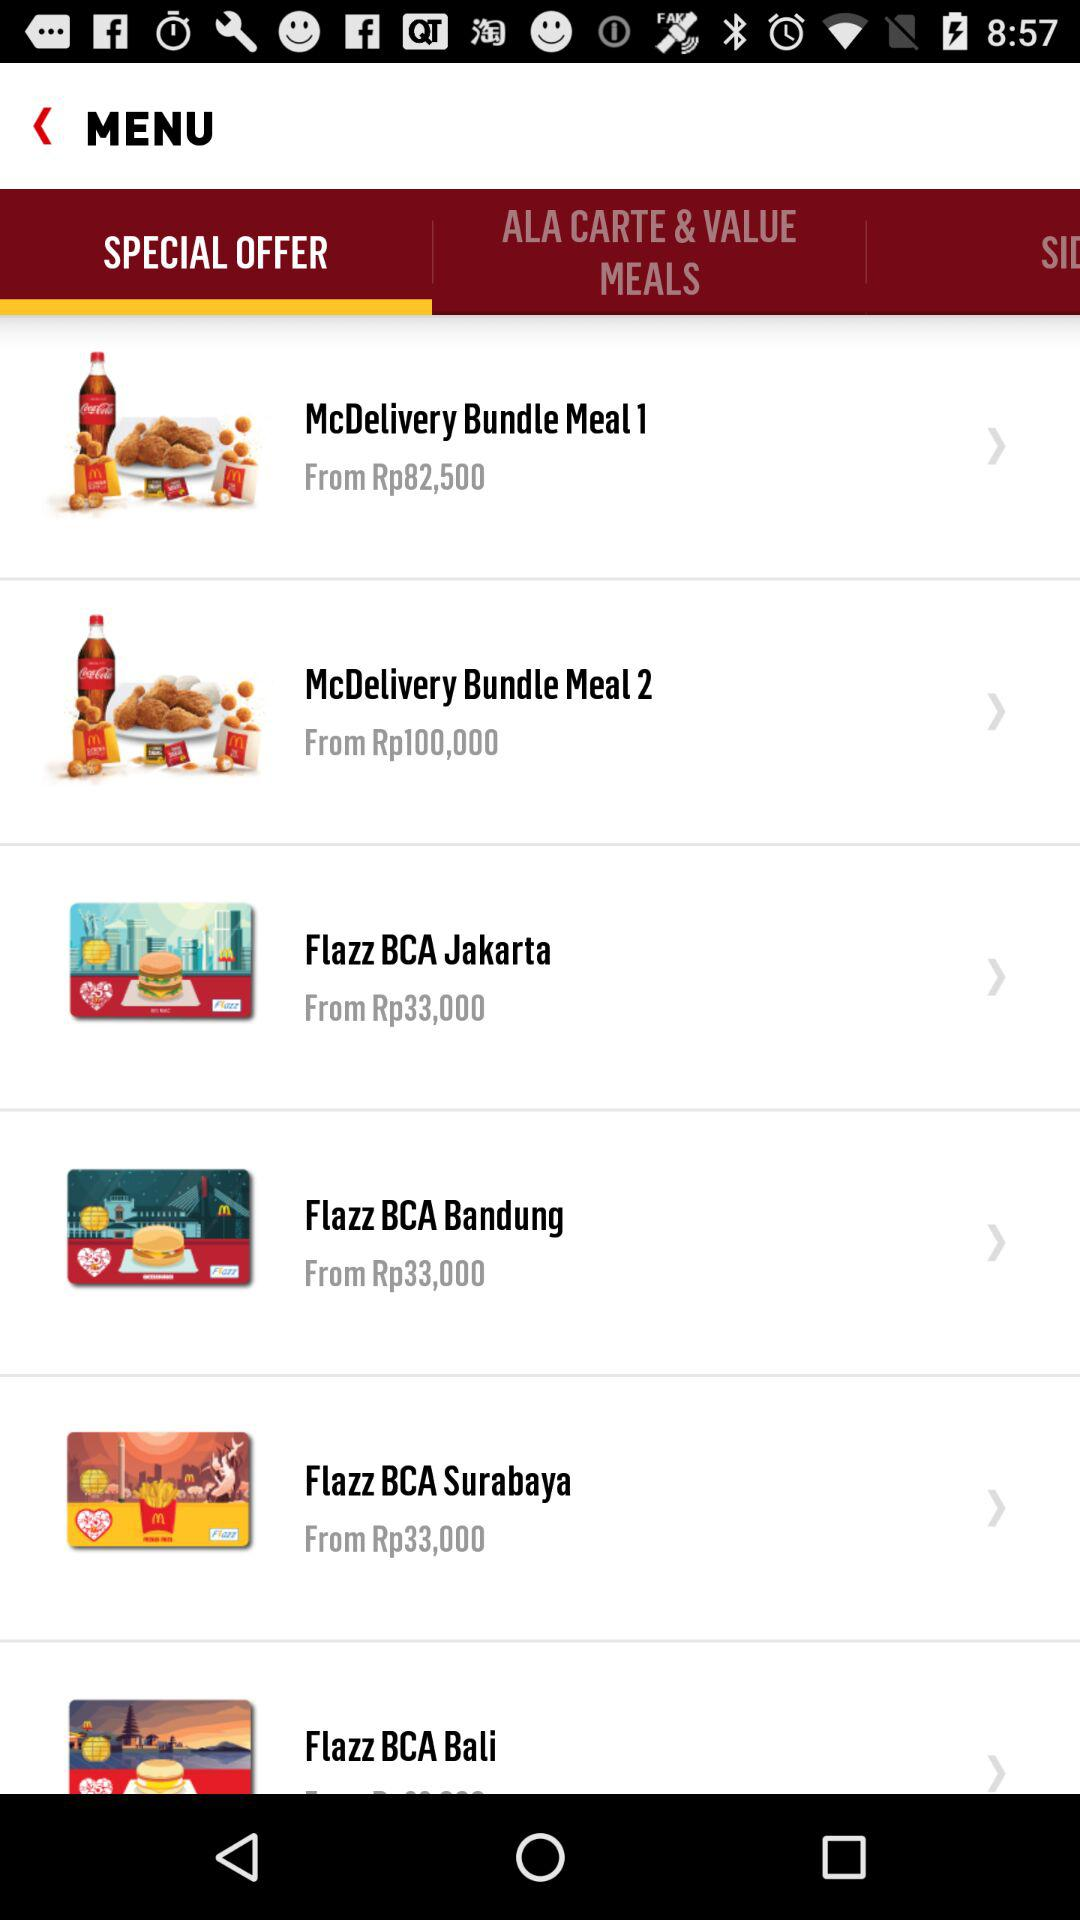Which tab is selected? The selected tab is "SPECIAL OFFER". 